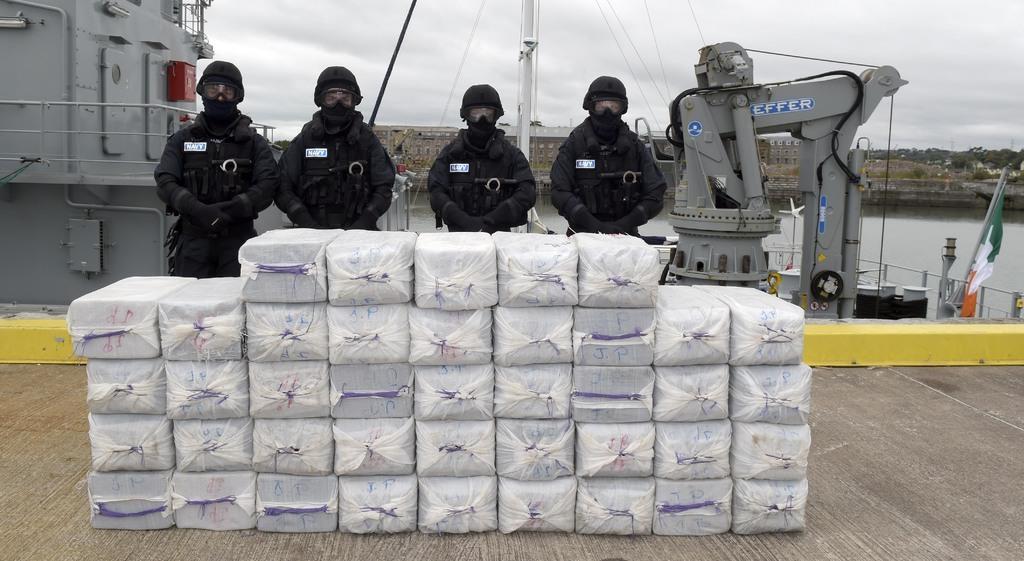Please provide a concise description of this image. In this picture, we can see a few people, and some white color objects on the ground, we can see metallic objects on the left side and right side of the picture, we can see flag, poles, wires, fencing, and some black color object, we can see water, the wall, ground, trees, and the sky with clouds. 